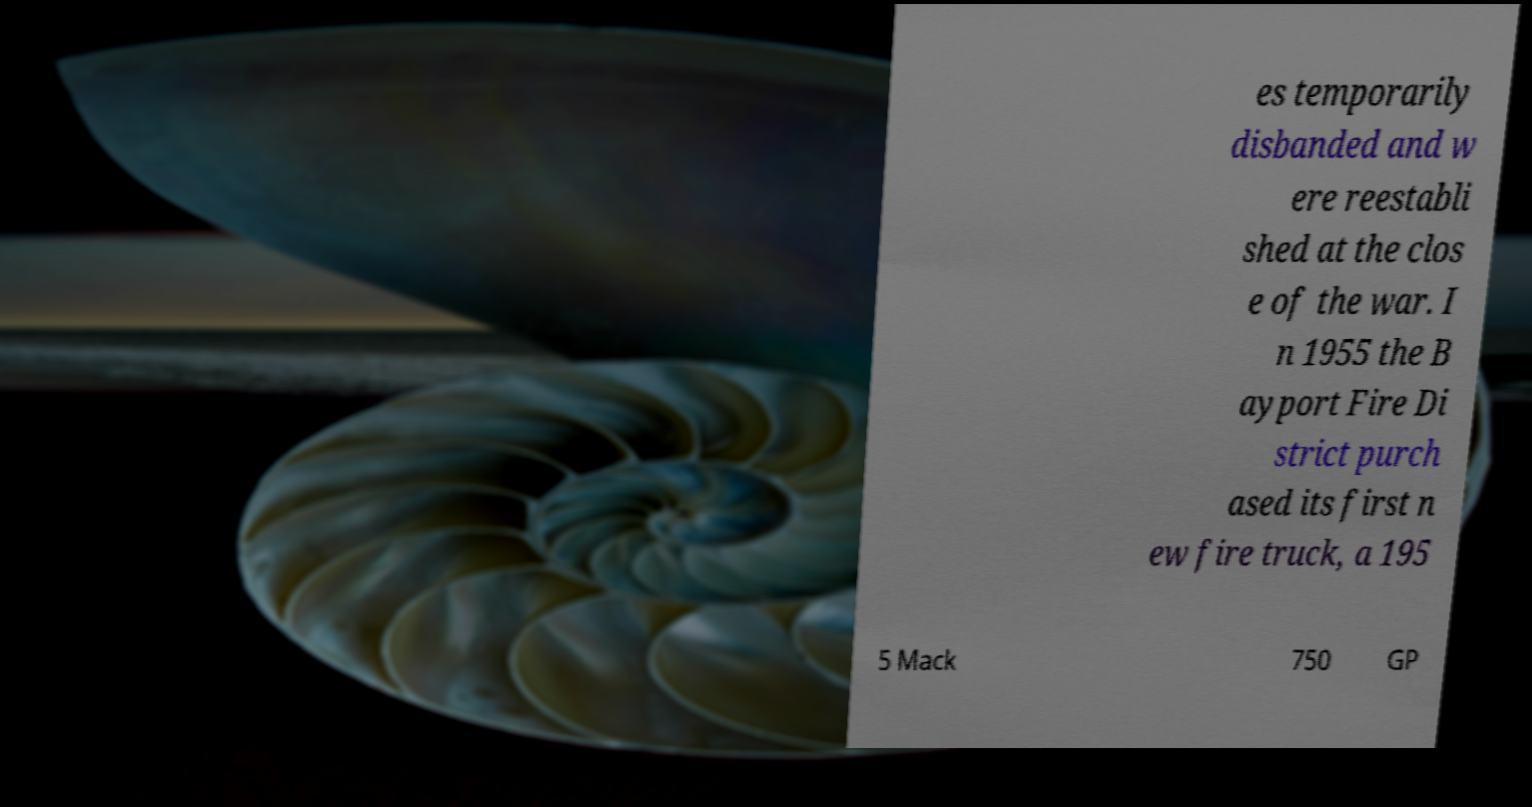Can you accurately transcribe the text from the provided image for me? es temporarily disbanded and w ere reestabli shed at the clos e of the war. I n 1955 the B ayport Fire Di strict purch ased its first n ew fire truck, a 195 5 Mack 750 GP 